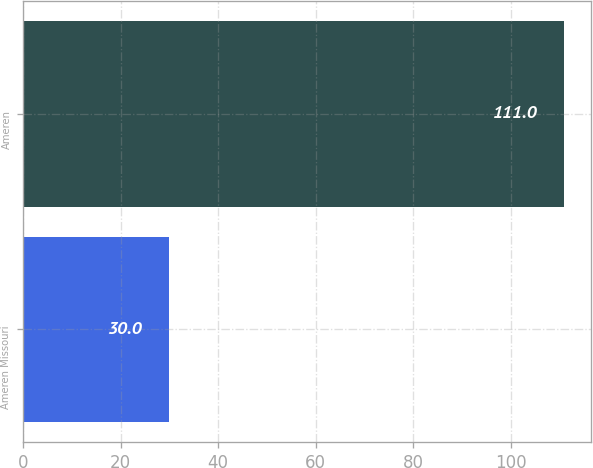Convert chart. <chart><loc_0><loc_0><loc_500><loc_500><bar_chart><fcel>Ameren Missouri<fcel>Ameren<nl><fcel>30<fcel>111<nl></chart> 